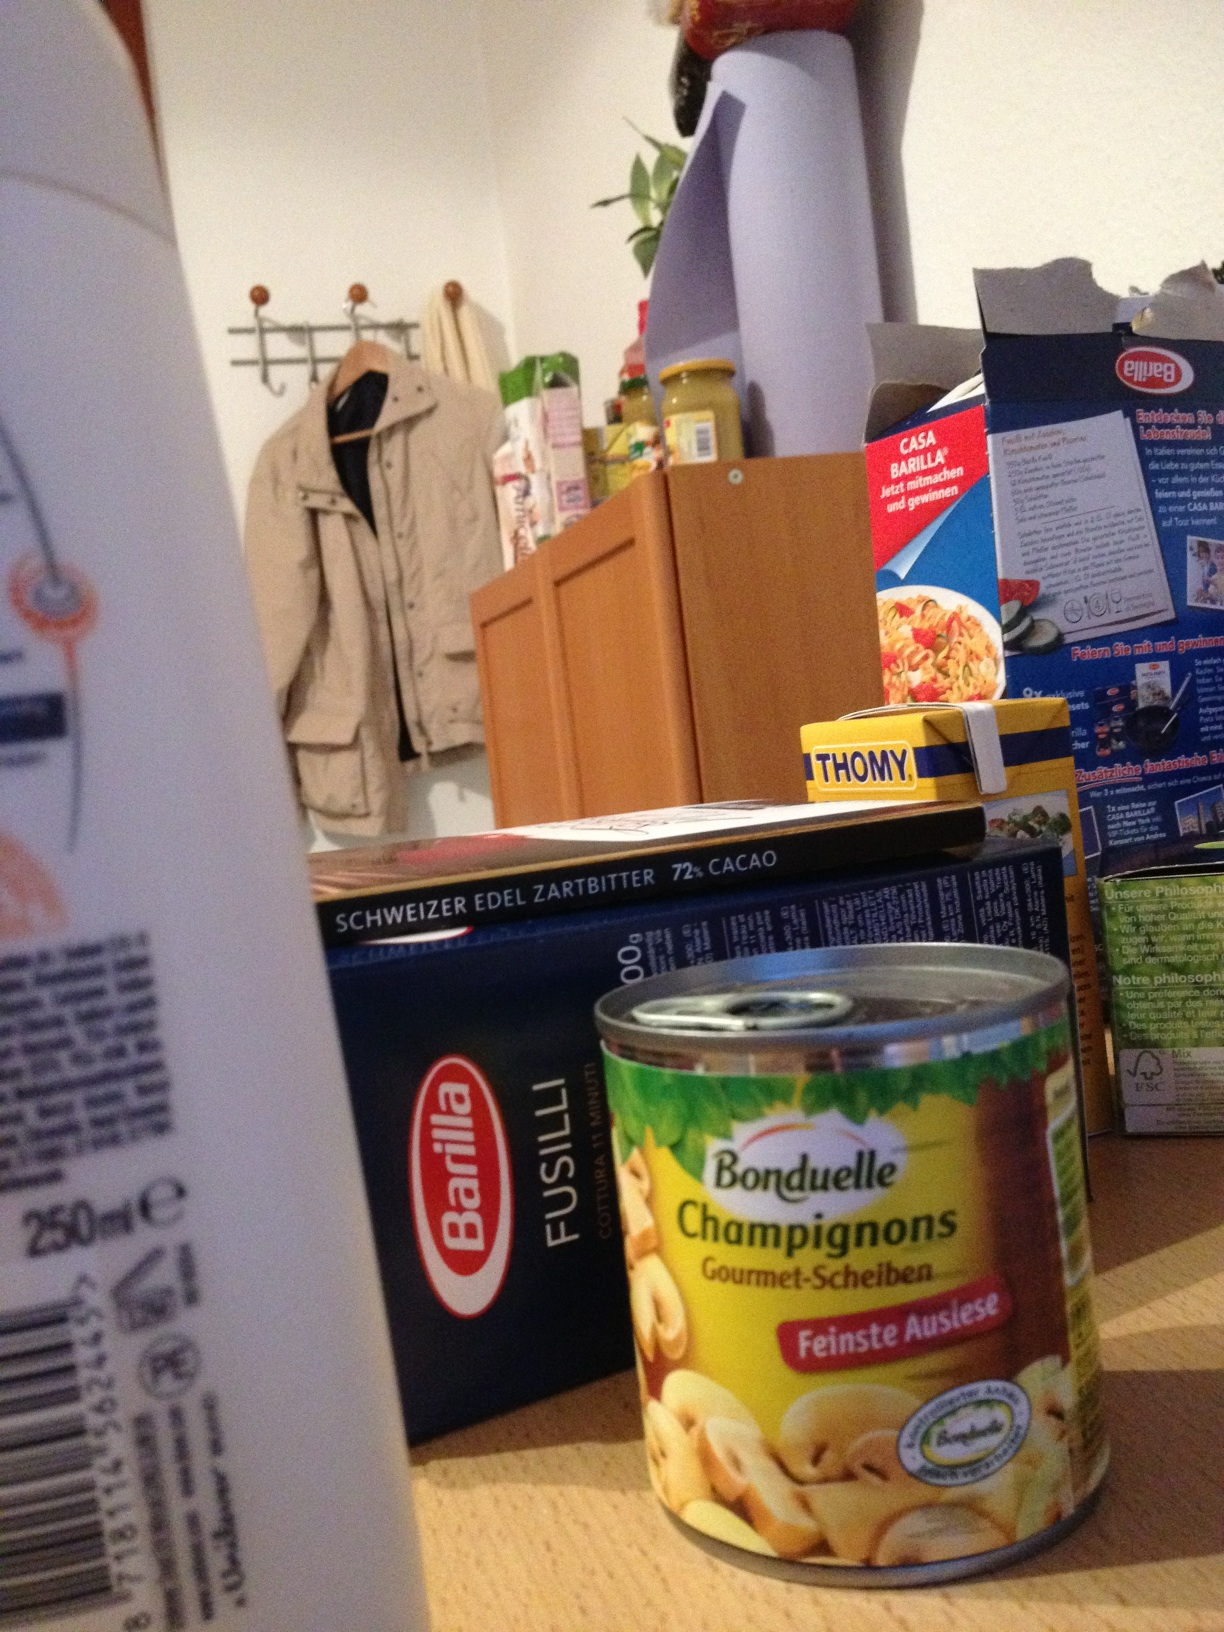Can you tell me more about the items on the kitchen counter? The kitchen counter contains various items, including a can of Bonduelle Gourmet Champignon mushrooms, Thomy mustard, Barilla Fusilli pasta, and a box of Swiss chocolate. These items suggest cooking and food preparation activities.  What can I cook with these ingredients? With the Fusilli pasta, mushrooms, and mustard, you could make a creamy mushroom pasta dish. Boil the pasta, sauté the mushrooms, and create a sauce with the mustard, cream, and some herbs. It’s a simple, delicious meal that can be enhanced with Swiss chocolate for dessert. 